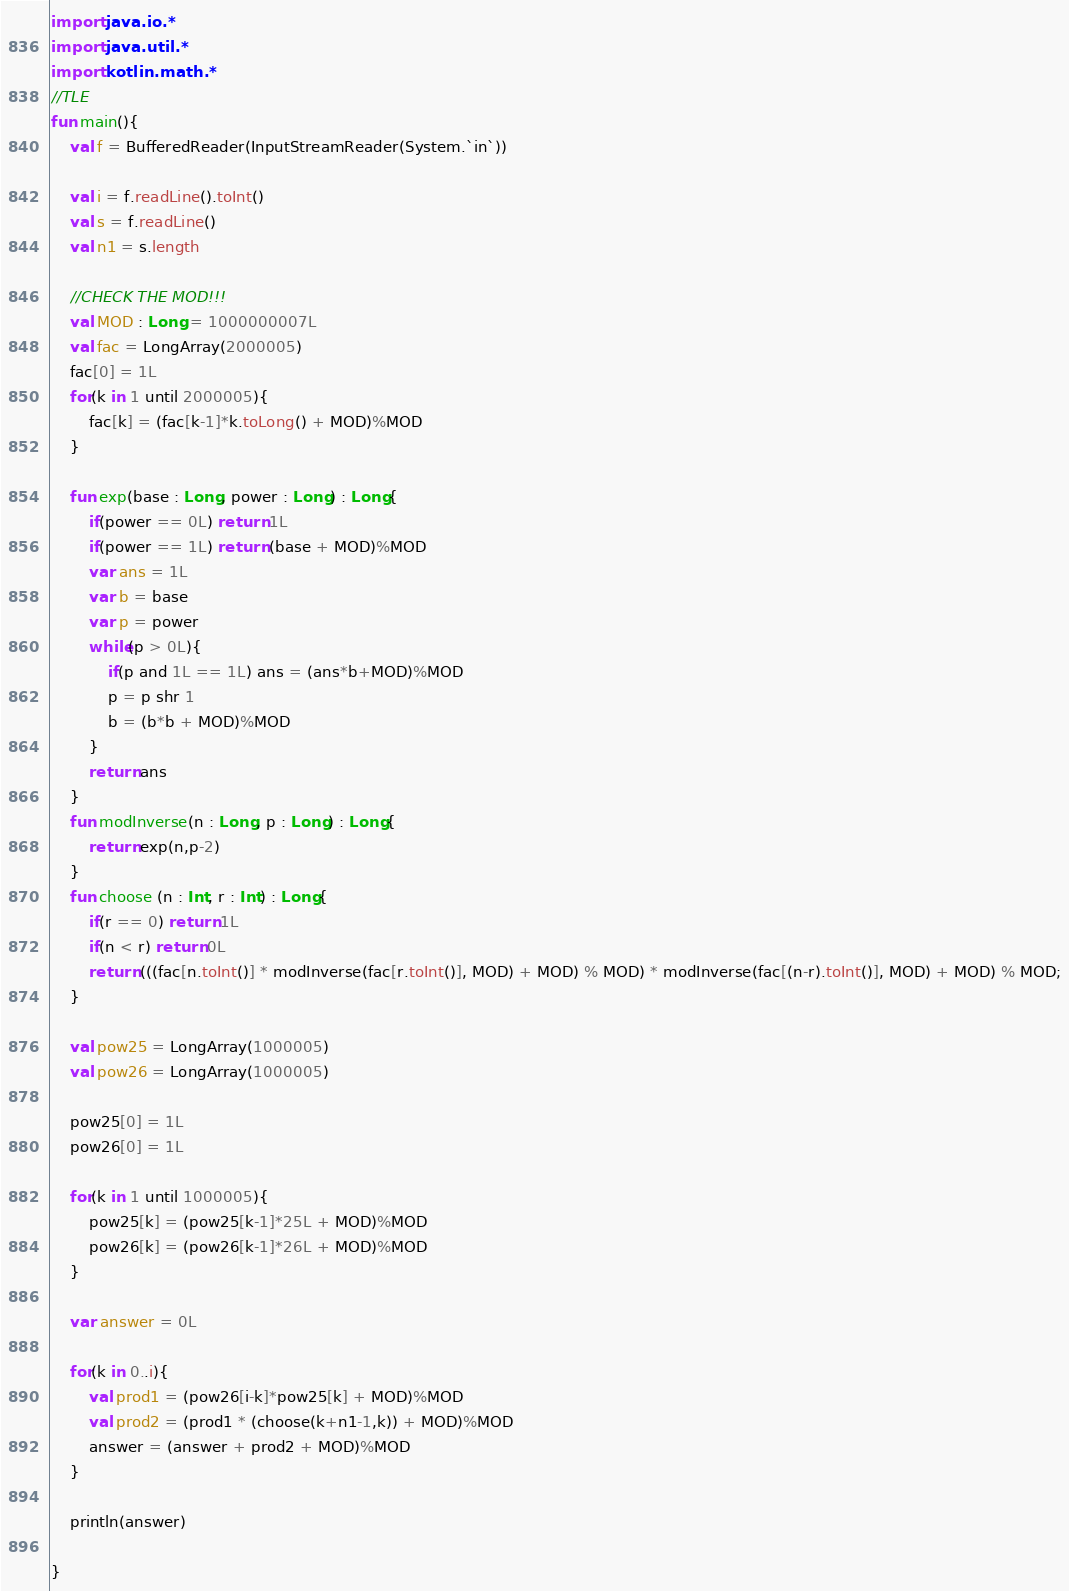Convert code to text. <code><loc_0><loc_0><loc_500><loc_500><_Kotlin_>import java.io.*
import java.util.*
import kotlin.math.*
//TLE
fun main(){
	val f = BufferedReader(InputStreamReader(System.`in`))

	val i = f.readLine().toInt()
	val s = f.readLine()
	val n1 = s.length

	//CHECK THE MOD!!!
	val MOD : Long = 1000000007L
	val fac = LongArray(2000005)
	fac[0] = 1L
	for(k in 1 until 2000005){
		fac[k] = (fac[k-1]*k.toLong() + MOD)%MOD
	}

	fun exp(base : Long, power : Long) : Long{
		if(power == 0L) return 1L
		if(power == 1L) return (base + MOD)%MOD
		var ans = 1L
		var b = base
		var p = power
		while(p > 0L){
			if(p and 1L == 1L) ans = (ans*b+MOD)%MOD
			p = p shr 1
			b = (b*b + MOD)%MOD
		}
		return ans
	}
	fun modInverse(n : Long, p : Long) : Long{
		return exp(n,p-2)
	}
	fun choose (n : Int, r : Int) : Long{
		if(r == 0) return 1L
		if(n < r) return 0L
		return (((fac[n.toInt()] * modInverse(fac[r.toInt()], MOD) + MOD) % MOD) * modInverse(fac[(n-r).toInt()], MOD) + MOD) % MOD;
	}

	val pow25 = LongArray(1000005)
	val pow26 = LongArray(1000005)

	pow25[0] = 1L
	pow26[0] = 1L

	for(k in 1 until 1000005){
		pow25[k] = (pow25[k-1]*25L + MOD)%MOD
		pow26[k] = (pow26[k-1]*26L + MOD)%MOD
	}

	var answer = 0L

	for(k in 0..i){
		val prod1 = (pow26[i-k]*pow25[k] + MOD)%MOD
		val prod2 = (prod1 * (choose(k+n1-1,k)) + MOD)%MOD
		answer = (answer + prod2 + MOD)%MOD
	}

	println(answer)

}
</code> 